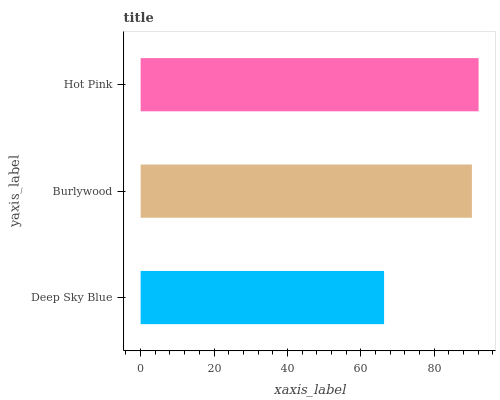Is Deep Sky Blue the minimum?
Answer yes or no. Yes. Is Hot Pink the maximum?
Answer yes or no. Yes. Is Burlywood the minimum?
Answer yes or no. No. Is Burlywood the maximum?
Answer yes or no. No. Is Burlywood greater than Deep Sky Blue?
Answer yes or no. Yes. Is Deep Sky Blue less than Burlywood?
Answer yes or no. Yes. Is Deep Sky Blue greater than Burlywood?
Answer yes or no. No. Is Burlywood less than Deep Sky Blue?
Answer yes or no. No. Is Burlywood the high median?
Answer yes or no. Yes. Is Burlywood the low median?
Answer yes or no. Yes. Is Hot Pink the high median?
Answer yes or no. No. Is Hot Pink the low median?
Answer yes or no. No. 